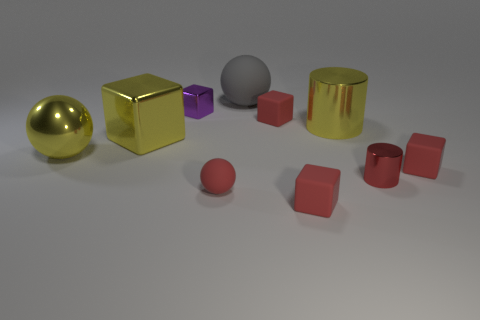What number of small objects are either red metal cylinders or gray matte things?
Ensure brevity in your answer.  1. Is the number of small purple things left of the small purple block the same as the number of yellow metal spheres that are right of the large metal ball?
Your answer should be very brief. Yes. What number of other objects are the same color as the tiny sphere?
Keep it short and to the point. 4. Are there the same number of cubes that are to the right of the purple block and yellow things?
Provide a succinct answer. Yes. Is the yellow metal ball the same size as the red rubber ball?
Your answer should be very brief. No. There is a ball that is behind the red shiny cylinder and in front of the purple metal object; what is it made of?
Make the answer very short. Metal. What number of big yellow things are the same shape as the purple thing?
Ensure brevity in your answer.  1. There is a yellow object on the right side of the small red rubber ball; what material is it?
Your response must be concise. Metal. Are there fewer cylinders behind the big yellow cylinder than purple shiny things?
Make the answer very short. Yes. Does the large rubber thing have the same shape as the small red metal object?
Your response must be concise. No. 